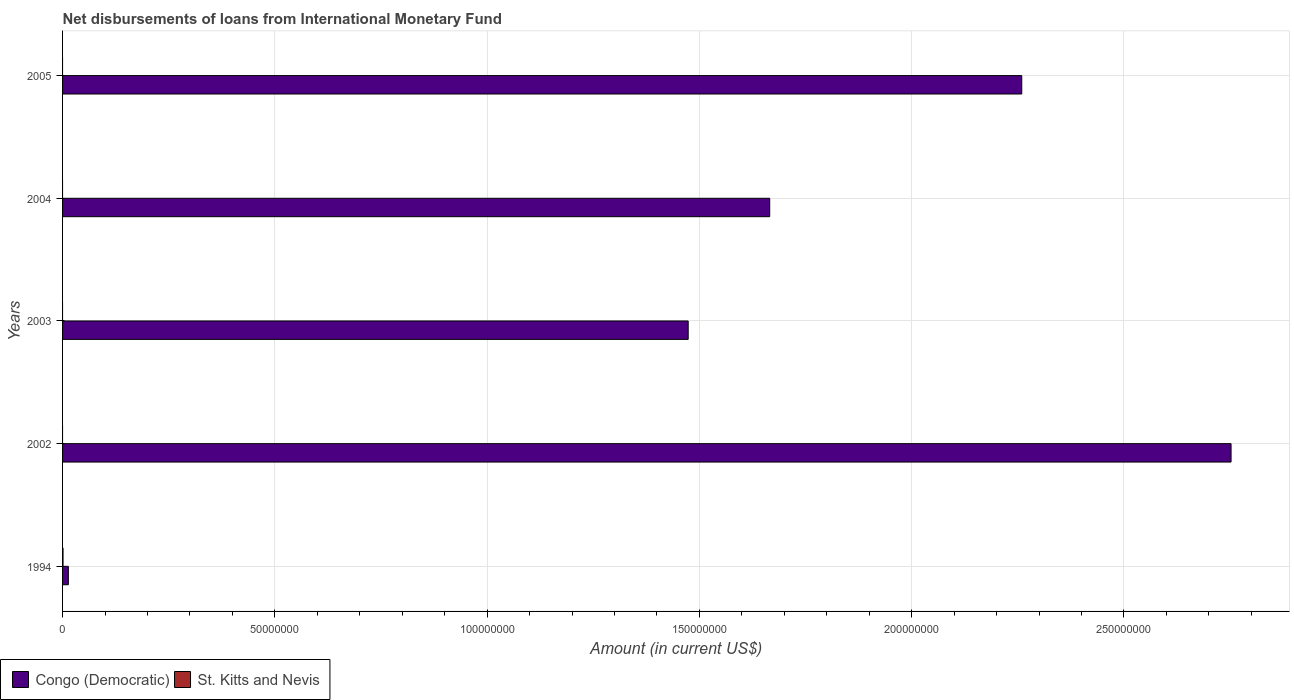How many different coloured bars are there?
Your response must be concise. 2. Are the number of bars per tick equal to the number of legend labels?
Keep it short and to the point. No. Are the number of bars on each tick of the Y-axis equal?
Keep it short and to the point. No. How many bars are there on the 1st tick from the bottom?
Your answer should be compact. 2. What is the label of the 4th group of bars from the top?
Your answer should be compact. 2002. In how many cases, is the number of bars for a given year not equal to the number of legend labels?
Provide a short and direct response. 4. What is the amount of loans disbursed in Congo (Democratic) in 2004?
Make the answer very short. 1.67e+08. Across all years, what is the maximum amount of loans disbursed in Congo (Democratic)?
Give a very brief answer. 2.75e+08. Across all years, what is the minimum amount of loans disbursed in Congo (Democratic)?
Provide a short and direct response. 1.36e+06. What is the total amount of loans disbursed in Congo (Democratic) in the graph?
Offer a very short reply. 8.16e+08. What is the difference between the amount of loans disbursed in Congo (Democratic) in 2003 and that in 2004?
Keep it short and to the point. -1.92e+07. What is the difference between the amount of loans disbursed in St. Kitts and Nevis in 2004 and the amount of loans disbursed in Congo (Democratic) in 2002?
Offer a very short reply. -2.75e+08. What is the average amount of loans disbursed in St. Kitts and Nevis per year?
Your answer should be very brief. 2.22e+04. In the year 1994, what is the difference between the amount of loans disbursed in Congo (Democratic) and amount of loans disbursed in St. Kitts and Nevis?
Your answer should be compact. 1.25e+06. In how many years, is the amount of loans disbursed in St. Kitts and Nevis greater than 270000000 US$?
Provide a short and direct response. 0. What is the ratio of the amount of loans disbursed in Congo (Democratic) in 1994 to that in 2004?
Provide a succinct answer. 0.01. What is the difference between the highest and the second highest amount of loans disbursed in Congo (Democratic)?
Make the answer very short. 4.93e+07. What is the difference between the highest and the lowest amount of loans disbursed in Congo (Democratic)?
Provide a short and direct response. 2.74e+08. In how many years, is the amount of loans disbursed in Congo (Democratic) greater than the average amount of loans disbursed in Congo (Democratic) taken over all years?
Offer a very short reply. 3. How many bars are there?
Offer a terse response. 6. Are all the bars in the graph horizontal?
Offer a terse response. Yes. What is the difference between two consecutive major ticks on the X-axis?
Give a very brief answer. 5.00e+07. Does the graph contain grids?
Ensure brevity in your answer.  Yes. Where does the legend appear in the graph?
Ensure brevity in your answer.  Bottom left. How are the legend labels stacked?
Offer a very short reply. Horizontal. What is the title of the graph?
Give a very brief answer. Net disbursements of loans from International Monetary Fund. What is the label or title of the X-axis?
Provide a succinct answer. Amount (in current US$). What is the Amount (in current US$) in Congo (Democratic) in 1994?
Offer a terse response. 1.36e+06. What is the Amount (in current US$) in St. Kitts and Nevis in 1994?
Your response must be concise. 1.11e+05. What is the Amount (in current US$) in Congo (Democratic) in 2002?
Provide a short and direct response. 2.75e+08. What is the Amount (in current US$) in Congo (Democratic) in 2003?
Make the answer very short. 1.47e+08. What is the Amount (in current US$) of St. Kitts and Nevis in 2003?
Ensure brevity in your answer.  0. What is the Amount (in current US$) of Congo (Democratic) in 2004?
Ensure brevity in your answer.  1.67e+08. What is the Amount (in current US$) of St. Kitts and Nevis in 2004?
Provide a short and direct response. 0. What is the Amount (in current US$) of Congo (Democratic) in 2005?
Offer a terse response. 2.26e+08. Across all years, what is the maximum Amount (in current US$) in Congo (Democratic)?
Give a very brief answer. 2.75e+08. Across all years, what is the maximum Amount (in current US$) of St. Kitts and Nevis?
Provide a succinct answer. 1.11e+05. Across all years, what is the minimum Amount (in current US$) of Congo (Democratic)?
Ensure brevity in your answer.  1.36e+06. Across all years, what is the minimum Amount (in current US$) in St. Kitts and Nevis?
Offer a very short reply. 0. What is the total Amount (in current US$) in Congo (Democratic) in the graph?
Give a very brief answer. 8.16e+08. What is the total Amount (in current US$) of St. Kitts and Nevis in the graph?
Give a very brief answer. 1.11e+05. What is the difference between the Amount (in current US$) of Congo (Democratic) in 1994 and that in 2002?
Your answer should be very brief. -2.74e+08. What is the difference between the Amount (in current US$) of Congo (Democratic) in 1994 and that in 2003?
Your response must be concise. -1.46e+08. What is the difference between the Amount (in current US$) in Congo (Democratic) in 1994 and that in 2004?
Provide a succinct answer. -1.65e+08. What is the difference between the Amount (in current US$) in Congo (Democratic) in 1994 and that in 2005?
Offer a terse response. -2.25e+08. What is the difference between the Amount (in current US$) in Congo (Democratic) in 2002 and that in 2003?
Make the answer very short. 1.28e+08. What is the difference between the Amount (in current US$) of Congo (Democratic) in 2002 and that in 2004?
Offer a terse response. 1.09e+08. What is the difference between the Amount (in current US$) in Congo (Democratic) in 2002 and that in 2005?
Provide a short and direct response. 4.93e+07. What is the difference between the Amount (in current US$) in Congo (Democratic) in 2003 and that in 2004?
Offer a very short reply. -1.92e+07. What is the difference between the Amount (in current US$) in Congo (Democratic) in 2003 and that in 2005?
Your response must be concise. -7.86e+07. What is the difference between the Amount (in current US$) in Congo (Democratic) in 2004 and that in 2005?
Keep it short and to the point. -5.94e+07. What is the average Amount (in current US$) in Congo (Democratic) per year?
Offer a very short reply. 1.63e+08. What is the average Amount (in current US$) in St. Kitts and Nevis per year?
Offer a very short reply. 2.22e+04. In the year 1994, what is the difference between the Amount (in current US$) in Congo (Democratic) and Amount (in current US$) in St. Kitts and Nevis?
Provide a succinct answer. 1.25e+06. What is the ratio of the Amount (in current US$) of Congo (Democratic) in 1994 to that in 2002?
Provide a succinct answer. 0.01. What is the ratio of the Amount (in current US$) in Congo (Democratic) in 1994 to that in 2003?
Make the answer very short. 0.01. What is the ratio of the Amount (in current US$) in Congo (Democratic) in 1994 to that in 2004?
Your answer should be compact. 0.01. What is the ratio of the Amount (in current US$) in Congo (Democratic) in 1994 to that in 2005?
Keep it short and to the point. 0.01. What is the ratio of the Amount (in current US$) of Congo (Democratic) in 2002 to that in 2003?
Ensure brevity in your answer.  1.87. What is the ratio of the Amount (in current US$) in Congo (Democratic) in 2002 to that in 2004?
Make the answer very short. 1.65. What is the ratio of the Amount (in current US$) in Congo (Democratic) in 2002 to that in 2005?
Provide a succinct answer. 1.22. What is the ratio of the Amount (in current US$) in Congo (Democratic) in 2003 to that in 2004?
Keep it short and to the point. 0.88. What is the ratio of the Amount (in current US$) of Congo (Democratic) in 2003 to that in 2005?
Give a very brief answer. 0.65. What is the ratio of the Amount (in current US$) of Congo (Democratic) in 2004 to that in 2005?
Give a very brief answer. 0.74. What is the difference between the highest and the second highest Amount (in current US$) of Congo (Democratic)?
Your answer should be compact. 4.93e+07. What is the difference between the highest and the lowest Amount (in current US$) of Congo (Democratic)?
Your response must be concise. 2.74e+08. What is the difference between the highest and the lowest Amount (in current US$) of St. Kitts and Nevis?
Give a very brief answer. 1.11e+05. 